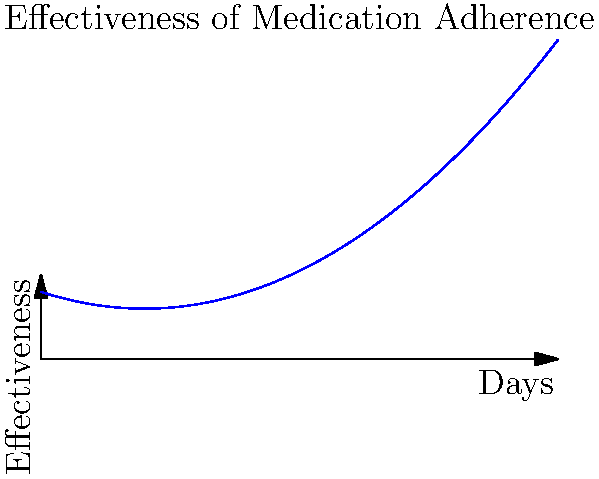A patient's medication effectiveness over time can be modeled by the polynomial function $f(x) = 0.8 - 0.2x + 0.05x^2$, where $x$ represents the number of days since starting the medication regimen and $f(x)$ represents the effectiveness score (0 to 1). On which day does the medication reach its minimum effectiveness? To find the day of minimum effectiveness, we need to follow these steps:

1) The minimum point of a quadratic function occurs at the vertex of the parabola.

2) For a quadratic function in the form $f(x) = ax^2 + bx + c$, the x-coordinate of the vertex is given by $x = -\frac{b}{2a}$.

3) In our function $f(x) = 0.8 - 0.2x + 0.05x^2$, we have:
   $a = 0.05$
   $b = -0.2$
   $c = 0.8$

4) Substituting into the vertex formula:
   $x = -\frac{-0.2}{2(0.05)} = \frac{0.2}{0.1} = 2$

5) Therefore, the minimum effectiveness occurs 2 days after starting the medication regimen.

6) Since we're asked for the day number, and we start counting from day 0, the answer is day 2.
Answer: Day 2 